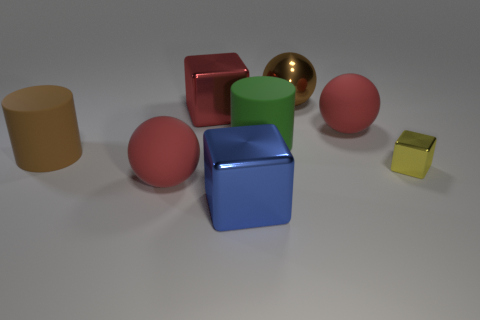Subtract all red cylinders. How many red spheres are left? 2 Subtract all red balls. How many balls are left? 1 Add 2 red spheres. How many objects exist? 10 Subtract all balls. How many objects are left? 5 Subtract all blue spheres. Subtract all purple cubes. How many spheres are left? 3 Subtract 0 cyan cylinders. How many objects are left? 8 Subtract all big red cubes. Subtract all small green cubes. How many objects are left? 7 Add 5 small yellow metallic things. How many small yellow metallic things are left? 6 Add 3 cyan objects. How many cyan objects exist? 3 